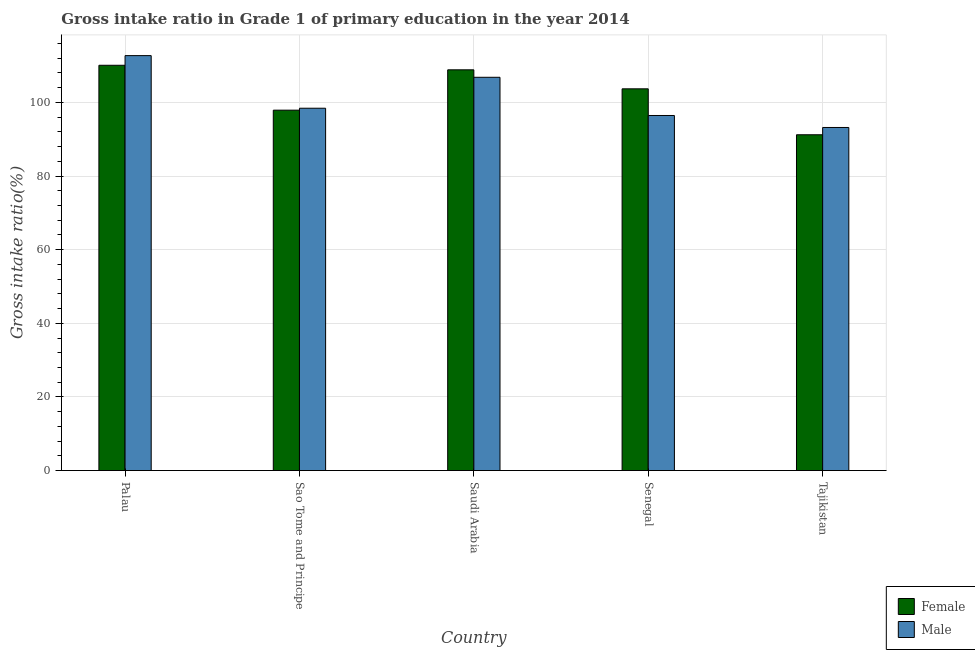How many different coloured bars are there?
Make the answer very short. 2. Are the number of bars per tick equal to the number of legend labels?
Offer a very short reply. Yes. How many bars are there on the 1st tick from the left?
Offer a very short reply. 2. How many bars are there on the 3rd tick from the right?
Make the answer very short. 2. What is the label of the 5th group of bars from the left?
Keep it short and to the point. Tajikistan. What is the gross intake ratio(female) in Senegal?
Ensure brevity in your answer.  103.69. Across all countries, what is the maximum gross intake ratio(female)?
Keep it short and to the point. 110.09. Across all countries, what is the minimum gross intake ratio(female)?
Your answer should be very brief. 91.22. In which country was the gross intake ratio(male) maximum?
Offer a terse response. Palau. In which country was the gross intake ratio(female) minimum?
Make the answer very short. Tajikistan. What is the total gross intake ratio(male) in the graph?
Your answer should be very brief. 507.61. What is the difference between the gross intake ratio(female) in Senegal and that in Tajikistan?
Provide a succinct answer. 12.48. What is the difference between the gross intake ratio(male) in Senegal and the gross intake ratio(female) in Saudi Arabia?
Keep it short and to the point. -12.41. What is the average gross intake ratio(female) per country?
Make the answer very short. 102.35. What is the difference between the gross intake ratio(female) and gross intake ratio(male) in Saudi Arabia?
Your response must be concise. 2.03. In how many countries, is the gross intake ratio(female) greater than 40 %?
Make the answer very short. 5. What is the ratio of the gross intake ratio(female) in Saudi Arabia to that in Senegal?
Provide a short and direct response. 1.05. Is the gross intake ratio(female) in Saudi Arabia less than that in Tajikistan?
Make the answer very short. No. Is the difference between the gross intake ratio(female) in Sao Tome and Principe and Senegal greater than the difference between the gross intake ratio(male) in Sao Tome and Principe and Senegal?
Keep it short and to the point. No. What is the difference between the highest and the second highest gross intake ratio(male)?
Your answer should be compact. 5.88. What is the difference between the highest and the lowest gross intake ratio(female)?
Offer a very short reply. 18.88. In how many countries, is the gross intake ratio(male) greater than the average gross intake ratio(male) taken over all countries?
Provide a succinct answer. 2. How many bars are there?
Keep it short and to the point. 10. Are all the bars in the graph horizontal?
Your answer should be very brief. No. What is the difference between two consecutive major ticks on the Y-axis?
Make the answer very short. 20. Does the graph contain any zero values?
Make the answer very short. No. Does the graph contain grids?
Provide a short and direct response. Yes. What is the title of the graph?
Provide a short and direct response. Gross intake ratio in Grade 1 of primary education in the year 2014. What is the label or title of the Y-axis?
Provide a short and direct response. Gross intake ratio(%). What is the Gross intake ratio(%) of Female in Palau?
Your response must be concise. 110.09. What is the Gross intake ratio(%) of Male in Palau?
Give a very brief answer. 112.71. What is the Gross intake ratio(%) in Female in Sao Tome and Principe?
Your answer should be very brief. 97.9. What is the Gross intake ratio(%) of Male in Sao Tome and Principe?
Your answer should be compact. 98.42. What is the Gross intake ratio(%) of Female in Saudi Arabia?
Provide a short and direct response. 108.86. What is the Gross intake ratio(%) in Male in Saudi Arabia?
Offer a very short reply. 106.83. What is the Gross intake ratio(%) in Female in Senegal?
Ensure brevity in your answer.  103.69. What is the Gross intake ratio(%) in Male in Senegal?
Offer a very short reply. 96.45. What is the Gross intake ratio(%) in Female in Tajikistan?
Offer a very short reply. 91.22. What is the Gross intake ratio(%) of Male in Tajikistan?
Provide a succinct answer. 93.19. Across all countries, what is the maximum Gross intake ratio(%) of Female?
Provide a short and direct response. 110.09. Across all countries, what is the maximum Gross intake ratio(%) in Male?
Offer a terse response. 112.71. Across all countries, what is the minimum Gross intake ratio(%) of Female?
Offer a very short reply. 91.22. Across all countries, what is the minimum Gross intake ratio(%) in Male?
Your answer should be very brief. 93.19. What is the total Gross intake ratio(%) of Female in the graph?
Make the answer very short. 511.76. What is the total Gross intake ratio(%) of Male in the graph?
Provide a short and direct response. 507.61. What is the difference between the Gross intake ratio(%) of Female in Palau and that in Sao Tome and Principe?
Your answer should be very brief. 12.2. What is the difference between the Gross intake ratio(%) in Male in Palau and that in Sao Tome and Principe?
Keep it short and to the point. 14.29. What is the difference between the Gross intake ratio(%) of Female in Palau and that in Saudi Arabia?
Keep it short and to the point. 1.23. What is the difference between the Gross intake ratio(%) of Male in Palau and that in Saudi Arabia?
Provide a short and direct response. 5.88. What is the difference between the Gross intake ratio(%) in Female in Palau and that in Senegal?
Ensure brevity in your answer.  6.4. What is the difference between the Gross intake ratio(%) in Male in Palau and that in Senegal?
Make the answer very short. 16.26. What is the difference between the Gross intake ratio(%) in Female in Palau and that in Tajikistan?
Offer a terse response. 18.88. What is the difference between the Gross intake ratio(%) in Male in Palau and that in Tajikistan?
Provide a short and direct response. 19.52. What is the difference between the Gross intake ratio(%) in Female in Sao Tome and Principe and that in Saudi Arabia?
Your answer should be very brief. -10.96. What is the difference between the Gross intake ratio(%) in Male in Sao Tome and Principe and that in Saudi Arabia?
Give a very brief answer. -8.4. What is the difference between the Gross intake ratio(%) in Female in Sao Tome and Principe and that in Senegal?
Make the answer very short. -5.8. What is the difference between the Gross intake ratio(%) in Male in Sao Tome and Principe and that in Senegal?
Ensure brevity in your answer.  1.97. What is the difference between the Gross intake ratio(%) of Female in Sao Tome and Principe and that in Tajikistan?
Provide a succinct answer. 6.68. What is the difference between the Gross intake ratio(%) in Male in Sao Tome and Principe and that in Tajikistan?
Make the answer very short. 5.23. What is the difference between the Gross intake ratio(%) in Female in Saudi Arabia and that in Senegal?
Offer a very short reply. 5.16. What is the difference between the Gross intake ratio(%) in Male in Saudi Arabia and that in Senegal?
Offer a very short reply. 10.38. What is the difference between the Gross intake ratio(%) of Female in Saudi Arabia and that in Tajikistan?
Give a very brief answer. 17.64. What is the difference between the Gross intake ratio(%) in Male in Saudi Arabia and that in Tajikistan?
Make the answer very short. 13.63. What is the difference between the Gross intake ratio(%) in Female in Senegal and that in Tajikistan?
Ensure brevity in your answer.  12.48. What is the difference between the Gross intake ratio(%) of Male in Senegal and that in Tajikistan?
Keep it short and to the point. 3.25. What is the difference between the Gross intake ratio(%) of Female in Palau and the Gross intake ratio(%) of Male in Sao Tome and Principe?
Your answer should be very brief. 11.67. What is the difference between the Gross intake ratio(%) in Female in Palau and the Gross intake ratio(%) in Male in Saudi Arabia?
Provide a succinct answer. 3.26. What is the difference between the Gross intake ratio(%) in Female in Palau and the Gross intake ratio(%) in Male in Senegal?
Offer a very short reply. 13.64. What is the difference between the Gross intake ratio(%) of Female in Palau and the Gross intake ratio(%) of Male in Tajikistan?
Provide a short and direct response. 16.9. What is the difference between the Gross intake ratio(%) in Female in Sao Tome and Principe and the Gross intake ratio(%) in Male in Saudi Arabia?
Your answer should be very brief. -8.93. What is the difference between the Gross intake ratio(%) of Female in Sao Tome and Principe and the Gross intake ratio(%) of Male in Senegal?
Make the answer very short. 1.45. What is the difference between the Gross intake ratio(%) in Female in Sao Tome and Principe and the Gross intake ratio(%) in Male in Tajikistan?
Keep it short and to the point. 4.7. What is the difference between the Gross intake ratio(%) of Female in Saudi Arabia and the Gross intake ratio(%) of Male in Senegal?
Keep it short and to the point. 12.41. What is the difference between the Gross intake ratio(%) of Female in Saudi Arabia and the Gross intake ratio(%) of Male in Tajikistan?
Keep it short and to the point. 15.66. What is the difference between the Gross intake ratio(%) in Female in Senegal and the Gross intake ratio(%) in Male in Tajikistan?
Keep it short and to the point. 10.5. What is the average Gross intake ratio(%) of Female per country?
Keep it short and to the point. 102.35. What is the average Gross intake ratio(%) in Male per country?
Make the answer very short. 101.52. What is the difference between the Gross intake ratio(%) of Female and Gross intake ratio(%) of Male in Palau?
Your response must be concise. -2.62. What is the difference between the Gross intake ratio(%) of Female and Gross intake ratio(%) of Male in Sao Tome and Principe?
Ensure brevity in your answer.  -0.53. What is the difference between the Gross intake ratio(%) of Female and Gross intake ratio(%) of Male in Saudi Arabia?
Provide a succinct answer. 2.03. What is the difference between the Gross intake ratio(%) in Female and Gross intake ratio(%) in Male in Senegal?
Provide a short and direct response. 7.24. What is the difference between the Gross intake ratio(%) of Female and Gross intake ratio(%) of Male in Tajikistan?
Provide a succinct answer. -1.98. What is the ratio of the Gross intake ratio(%) of Female in Palau to that in Sao Tome and Principe?
Offer a terse response. 1.12. What is the ratio of the Gross intake ratio(%) of Male in Palau to that in Sao Tome and Principe?
Your answer should be compact. 1.15. What is the ratio of the Gross intake ratio(%) of Female in Palau to that in Saudi Arabia?
Your response must be concise. 1.01. What is the ratio of the Gross intake ratio(%) in Male in Palau to that in Saudi Arabia?
Offer a terse response. 1.06. What is the ratio of the Gross intake ratio(%) of Female in Palau to that in Senegal?
Ensure brevity in your answer.  1.06. What is the ratio of the Gross intake ratio(%) in Male in Palau to that in Senegal?
Your response must be concise. 1.17. What is the ratio of the Gross intake ratio(%) in Female in Palau to that in Tajikistan?
Provide a succinct answer. 1.21. What is the ratio of the Gross intake ratio(%) of Male in Palau to that in Tajikistan?
Ensure brevity in your answer.  1.21. What is the ratio of the Gross intake ratio(%) of Female in Sao Tome and Principe to that in Saudi Arabia?
Offer a terse response. 0.9. What is the ratio of the Gross intake ratio(%) in Male in Sao Tome and Principe to that in Saudi Arabia?
Keep it short and to the point. 0.92. What is the ratio of the Gross intake ratio(%) of Female in Sao Tome and Principe to that in Senegal?
Provide a succinct answer. 0.94. What is the ratio of the Gross intake ratio(%) of Male in Sao Tome and Principe to that in Senegal?
Ensure brevity in your answer.  1.02. What is the ratio of the Gross intake ratio(%) of Female in Sao Tome and Principe to that in Tajikistan?
Ensure brevity in your answer.  1.07. What is the ratio of the Gross intake ratio(%) of Male in Sao Tome and Principe to that in Tajikistan?
Your answer should be very brief. 1.06. What is the ratio of the Gross intake ratio(%) of Female in Saudi Arabia to that in Senegal?
Provide a short and direct response. 1.05. What is the ratio of the Gross intake ratio(%) of Male in Saudi Arabia to that in Senegal?
Offer a terse response. 1.11. What is the ratio of the Gross intake ratio(%) in Female in Saudi Arabia to that in Tajikistan?
Provide a short and direct response. 1.19. What is the ratio of the Gross intake ratio(%) in Male in Saudi Arabia to that in Tajikistan?
Make the answer very short. 1.15. What is the ratio of the Gross intake ratio(%) of Female in Senegal to that in Tajikistan?
Your response must be concise. 1.14. What is the ratio of the Gross intake ratio(%) of Male in Senegal to that in Tajikistan?
Provide a short and direct response. 1.03. What is the difference between the highest and the second highest Gross intake ratio(%) of Female?
Your answer should be compact. 1.23. What is the difference between the highest and the second highest Gross intake ratio(%) in Male?
Offer a very short reply. 5.88. What is the difference between the highest and the lowest Gross intake ratio(%) of Female?
Provide a succinct answer. 18.88. What is the difference between the highest and the lowest Gross intake ratio(%) of Male?
Give a very brief answer. 19.52. 